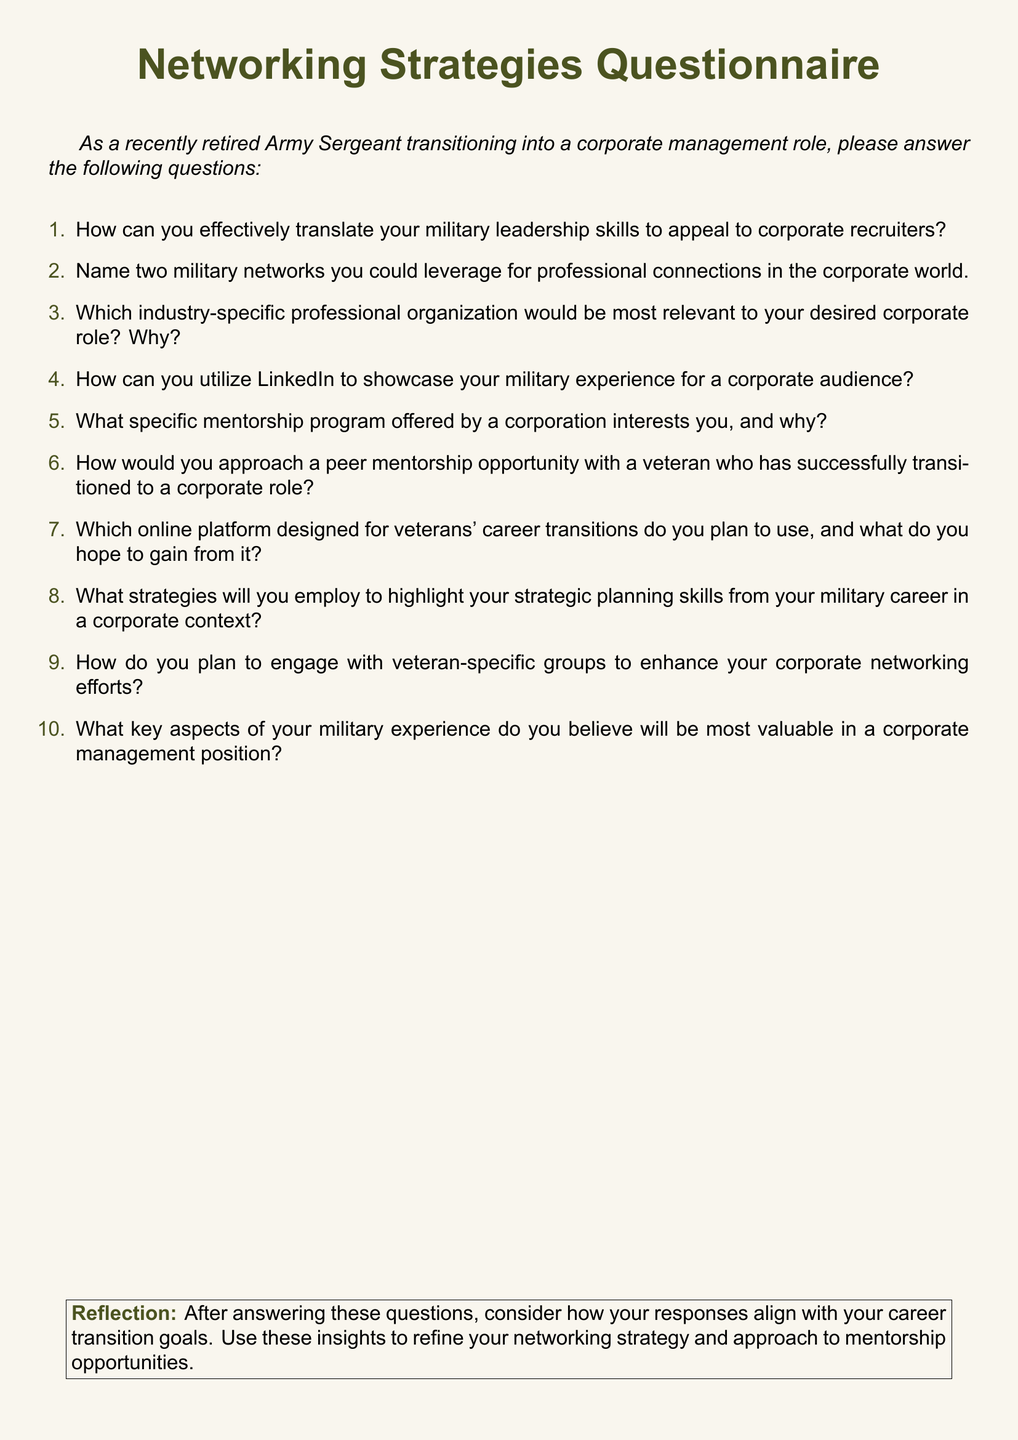How many questions are in the document? The document contains a list of 10 questions for the questionnaire.
Answer: 10 What color is used for the main title text? The main title text is formatted in military green color as defined in the document.
Answer: military green Which section of the document discusses reflection? The reflection is presented in a boxed section at the bottom of the document.
Answer: Reflection What is one military network you could leverage? One selection from the answers could be any military network mentioned relevant to corporate connections.
Answer: [Any relevant military network] Which online platform is designed for veterans' career transitions? This refers to any online platform specifically aimed at helping veterans transition to civilian careers.
Answer: [Any relevant online platform] How can you showcase military experience on LinkedIn? The document asks about utilizing LinkedIn for this purpose but the specific way to do it is the answer you need.
Answer: [Any relevant method referenced] What type of experience is most valuable in a corporate management position? This question seeks the key aspects of military experience that would be useful in management.
Answer: [Any relevant aspect mentioned] 